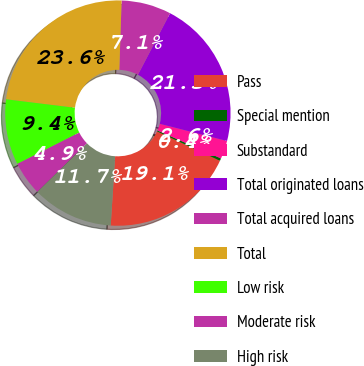Convert chart to OTSL. <chart><loc_0><loc_0><loc_500><loc_500><pie_chart><fcel>Pass<fcel>Special mention<fcel>Substandard<fcel>Total originated loans<fcel>Total acquired loans<fcel>Total<fcel>Low risk<fcel>Moderate risk<fcel>High risk<nl><fcel>19.06%<fcel>0.36%<fcel>2.62%<fcel>21.32%<fcel>7.14%<fcel>23.58%<fcel>9.4%<fcel>4.88%<fcel>11.66%<nl></chart> 